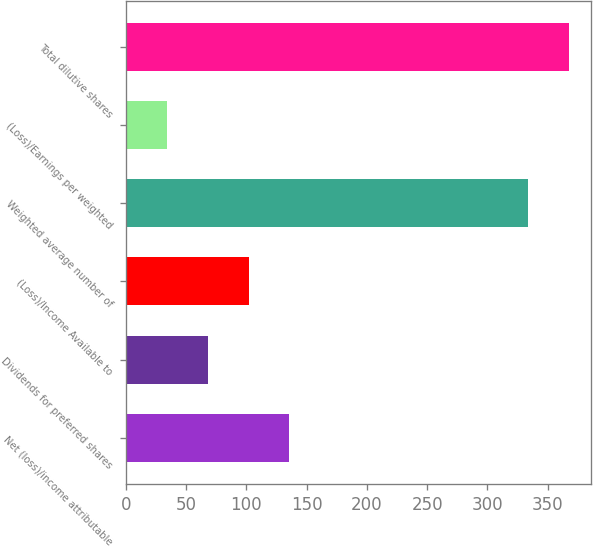<chart> <loc_0><loc_0><loc_500><loc_500><bar_chart><fcel>Net (loss)/income attributable<fcel>Dividends for preferred shares<fcel>(Loss)/Income Available to<fcel>Weighted average number of<fcel>(Loss)/Earnings per weighted<fcel>Total dilutive shares<nl><fcel>135.75<fcel>67.99<fcel>101.87<fcel>334<fcel>34.11<fcel>367.88<nl></chart> 